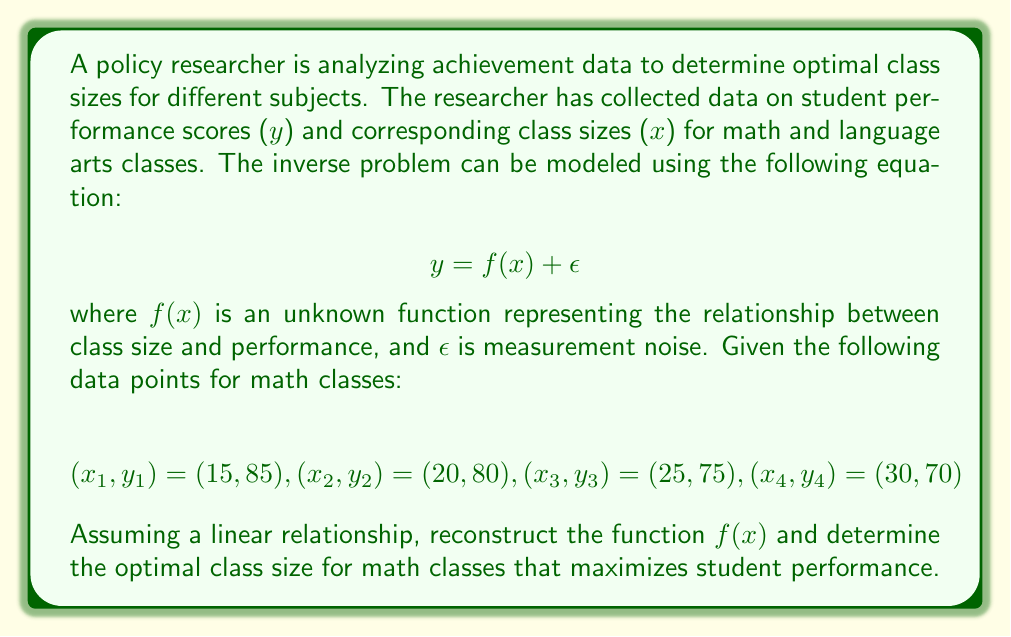Can you solve this math problem? To solve this inverse problem and reconstruct the optimal class size, we'll follow these steps:

1. Assume a linear relationship: $f(x) = ax + b$

2. Use the given data points to create a system of equations:
   $$85 = 15a + b$$
   $$80 = 20a + b$$
   $$75 = 25a + b$$
   $$70 = 30a + b$$

3. Subtract consecutive equations to eliminate $b$:
   $$85 - 80 = 15a - 20a \Rightarrow -5 = -5a$$
   $$80 - 75 = 20a - 25a \Rightarrow -5 = -5a$$
   $$75 - 70 = 25a - 30a \Rightarrow -5 = -5a$$

4. Solve for $a$:
   $$a = 1$$

5. Substitute $a = 1$ into any of the original equations to solve for $b$:
   $$85 = 15(1) + b \Rightarrow b = 70$$

6. The reconstructed function is:
   $$f(x) = x + 70$$

7. To find the optimal class size, we need to maximize $f(x)$. Since the function is decreasing (negative slope), the optimal class size is the smallest possible value.

8. Assuming a minimum class size of 15 students (based on the given data), the optimal class size that maximizes student performance is 15.
Answer: 15 students 